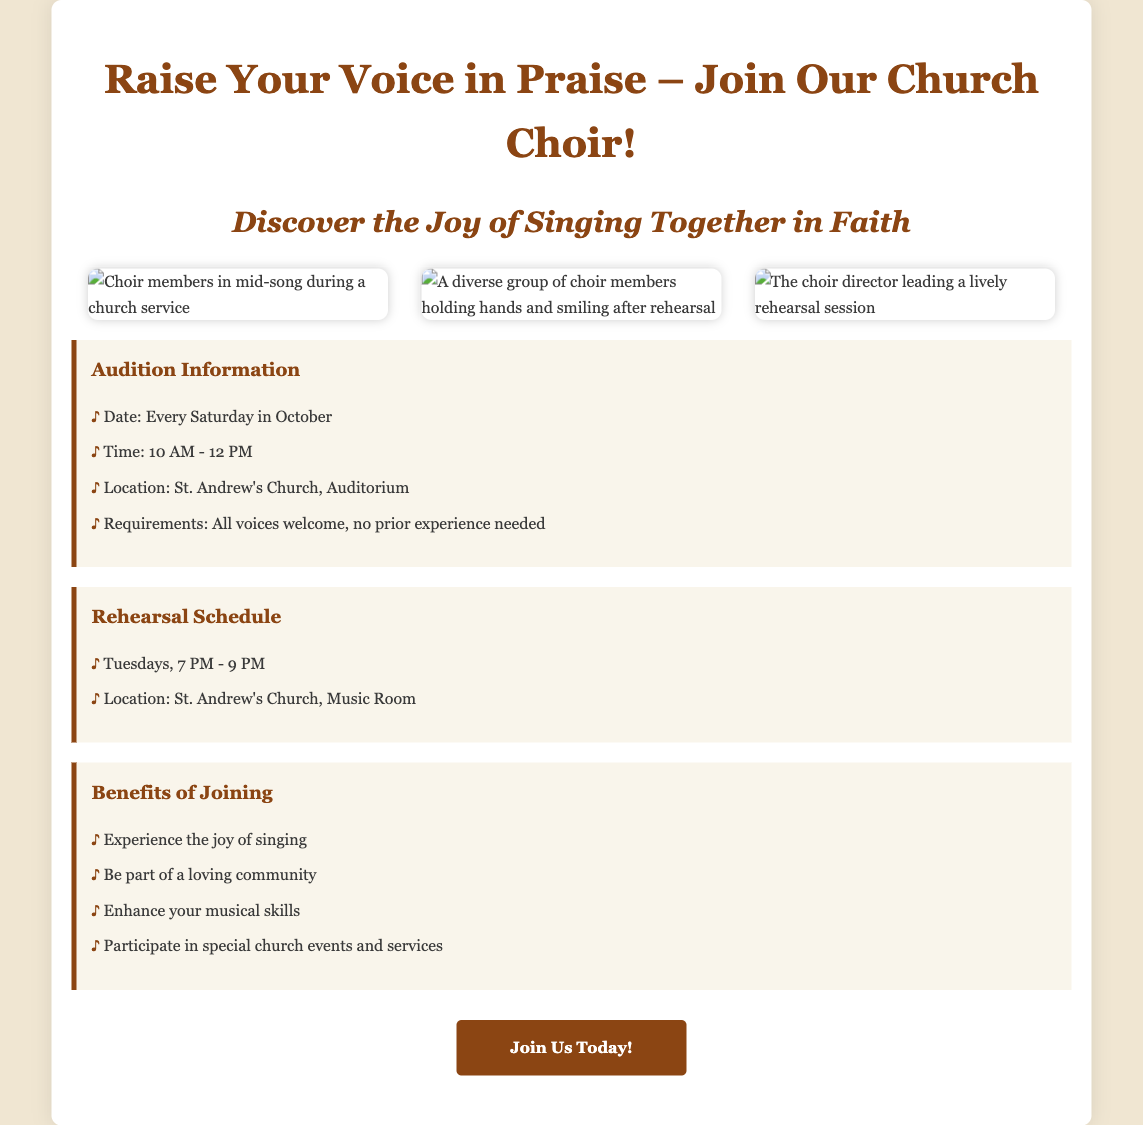What is the motto of the choir? The motto of the choir is presented in the title of the advertisement, emphasizing the act of praise through singing.
Answer: Raise Your Voice in Praise When do the auditions take place? The auditions are scheduled every Saturday in October according to the audition information provided.
Answer: Every Saturday in October What time do auditions start? The document specifies the time for auditions, which is stated in the audition information section.
Answer: 10 AM Where are the rehearsals held? The rehearsal location is mentioned in the rehearsal schedule section of the advertisement.
Answer: St. Andrew's Church, Music Room What is one requirement for joining the choir? The advertisement lists requirements for auditions, indicating the inclusivity of the choir membership.
Answer: No prior experience needed What day of the week are rehearsals scheduled? The document clearly states the day and time for rehearsals, helping potential members know when to attend.
Answer: Tuesdays What benefit is mentioned about joining the choir? The advertisement highlights several benefits of joining, focusing on the positive experiences of members.
Answer: Experience the joy of singing How long do rehearsals last? The rehearsal schedule provides details on the duration of the sessions, indicating a set timeframe for each.
Answer: 2 hours 